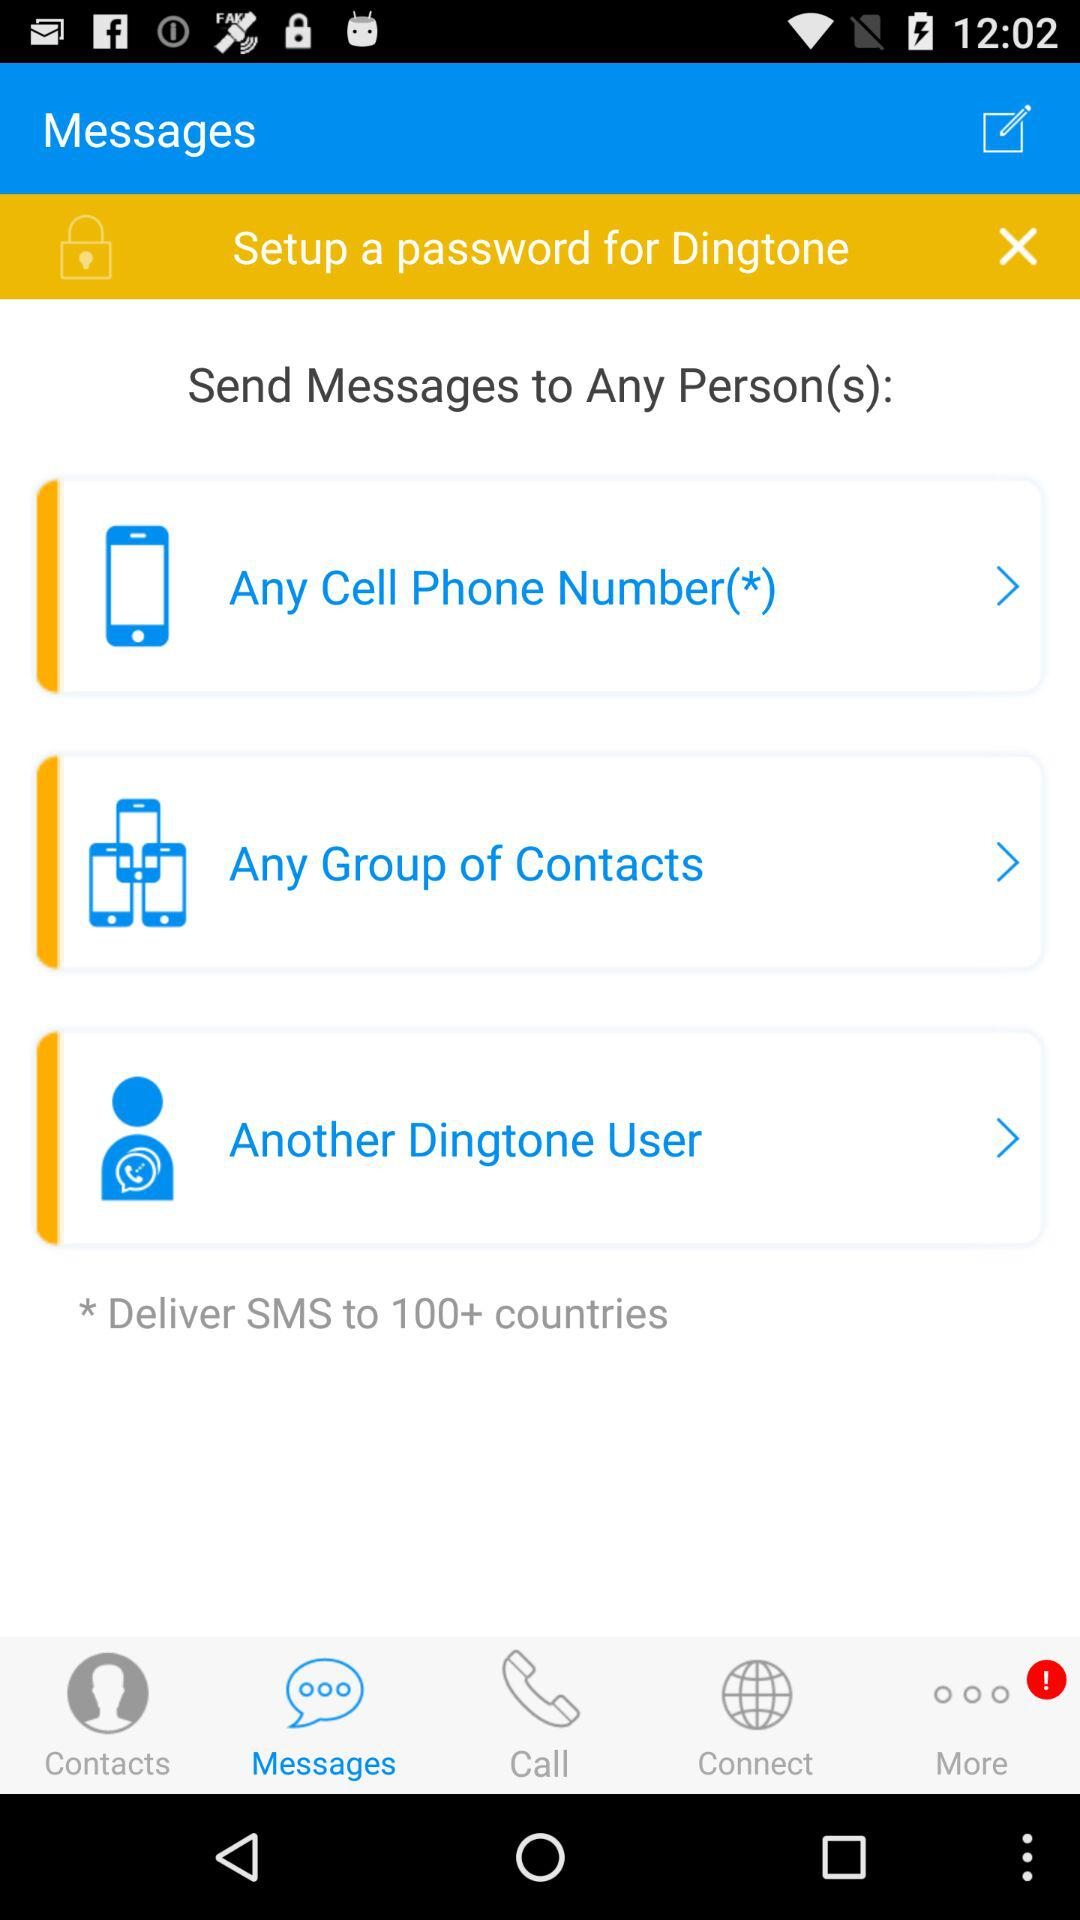What application is asking to set up a password? The application is "Dingtone". 